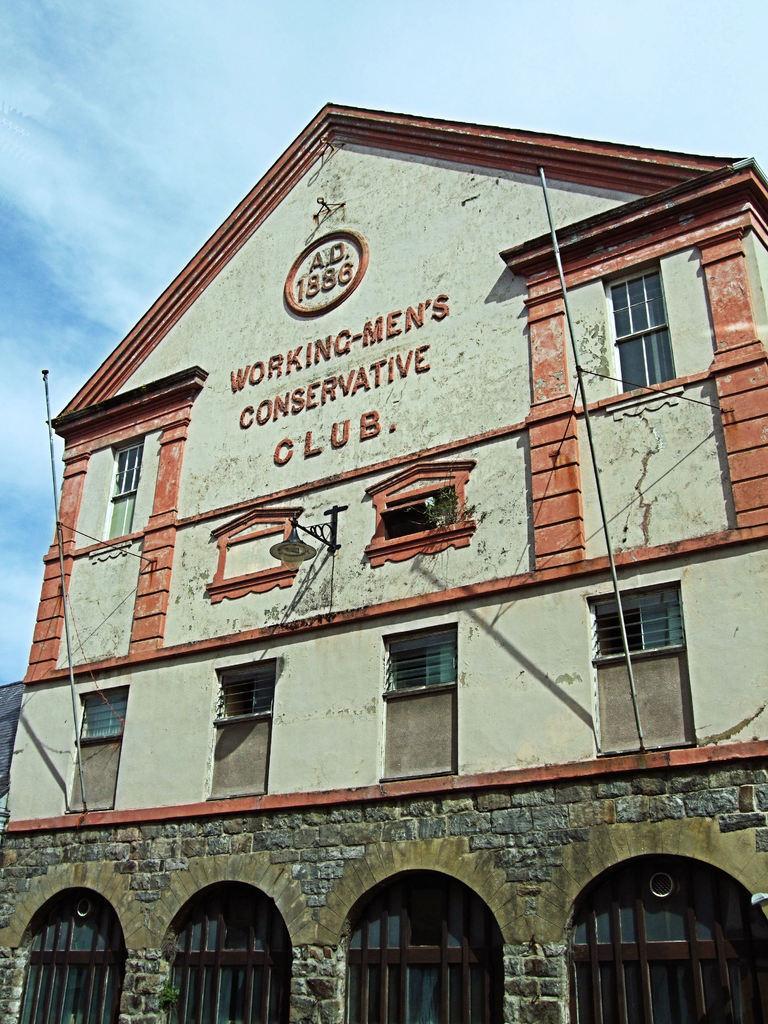Could you give a brief overview of what you see in this image? We can see building, windows and lights. In the background we can see sky with clouds. 